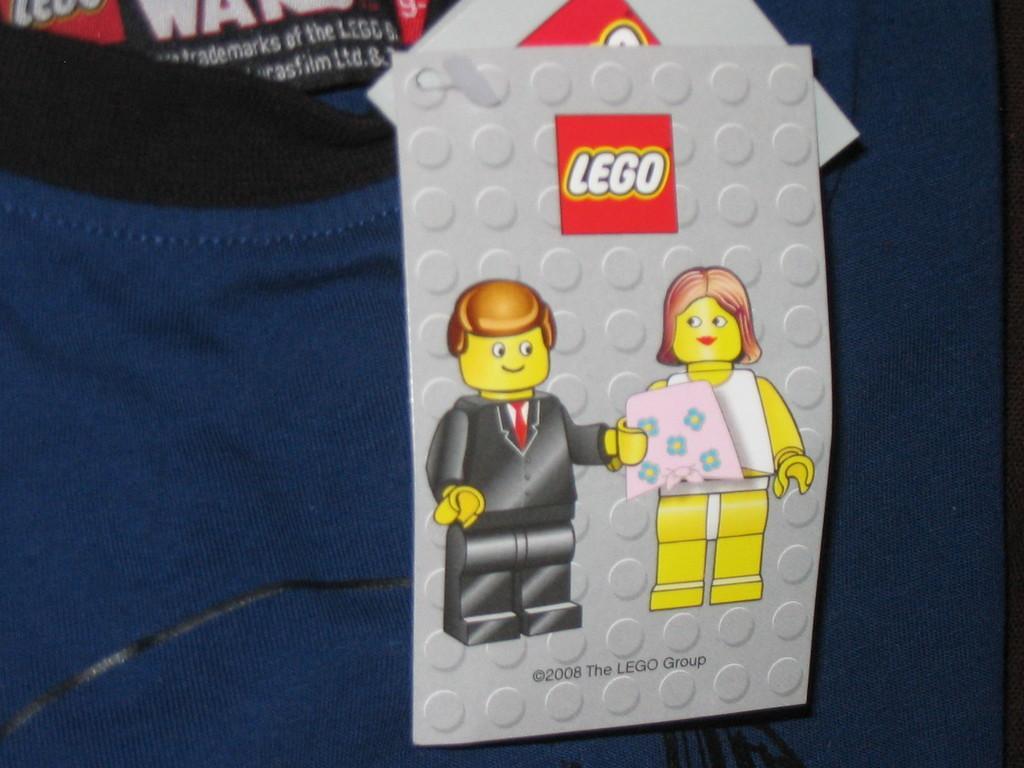In one or two sentences, can you explain what this image depicts? There is a violet color t-shirt, which is having two gray color cards. On the first card, there are two animated images and a watermark. 